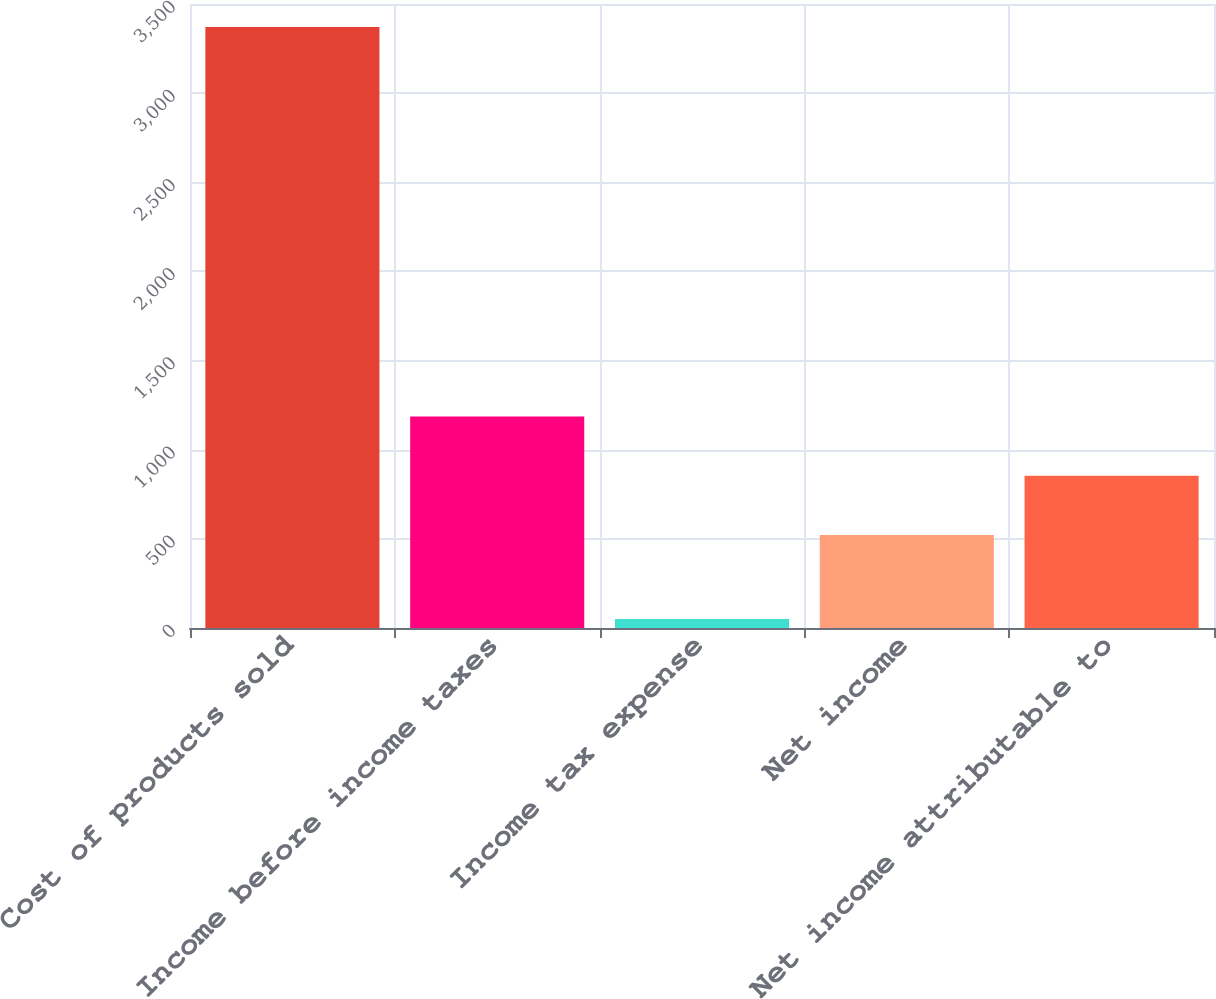Convert chart to OTSL. <chart><loc_0><loc_0><loc_500><loc_500><bar_chart><fcel>Cost of products sold<fcel>Income before income taxes<fcel>Income tax expense<fcel>Net income<fcel>Net income attributable to<nl><fcel>3371<fcel>1186<fcel>51<fcel>522<fcel>854<nl></chart> 